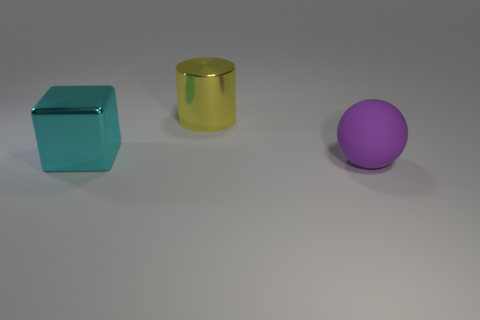Are there any other things that have the same material as the large ball?
Make the answer very short. No. Are there any yellow metallic cubes of the same size as the cyan metal block?
Give a very brief answer. No. Is the number of big rubber objects that are behind the cyan cube the same as the number of large balls that are left of the purple rubber object?
Make the answer very short. Yes. Are the object that is to the left of the big yellow metallic thing and the big thing that is on the right side of the yellow metal object made of the same material?
Provide a short and direct response. No. What material is the big yellow thing?
Provide a succinct answer. Metal. What number of other things are the same color as the metallic cube?
Offer a very short reply. 0. Does the ball have the same color as the block?
Your answer should be very brief. No. How many large brown rubber balls are there?
Make the answer very short. 0. The object right of the big object behind the big metallic cube is made of what material?
Your answer should be very brief. Rubber. There is a yellow object that is the same size as the cyan metal block; what is its material?
Your response must be concise. Metal. 